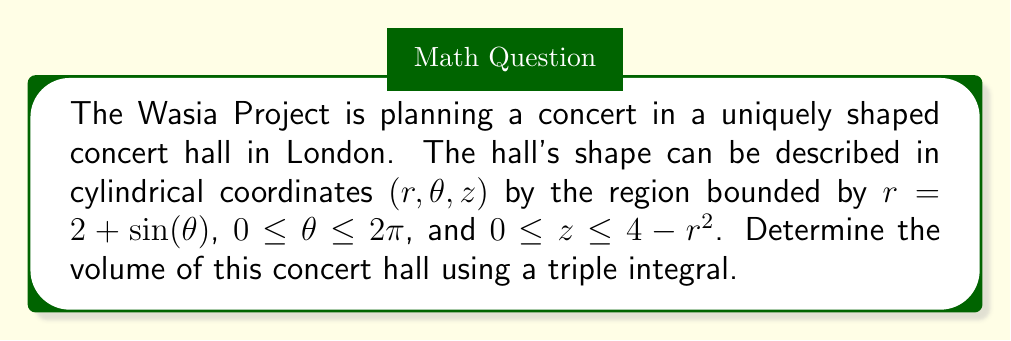Provide a solution to this math problem. To solve this problem, we'll use a triple integral in cylindrical coordinates. The steps are as follows:

1) The volume in cylindrical coordinates is given by the triple integral:

   $$V = \iiint_V r \, dr \, d\theta \, dz$$

2) From the given information, we have:
   $0 \leq \theta \leq 2\pi$
   $0 \leq r \leq 2 + \sin(\theta)$
   $0 \leq z \leq 4 - r^2$

3) We set up the triple integral:

   $$V = \int_0^{2\pi} \int_0^{2+\sin(\theta)} \int_0^{4-r^2} r \, dz \, dr \, d\theta$$

4) Let's evaluate the innermost integral first:

   $$V = \int_0^{2\pi} \int_0^{2+\sin(\theta)} r \left[ z \right]_0^{4-r^2} \, dr \, d\theta$$
   $$= \int_0^{2\pi} \int_0^{2+\sin(\theta)} r(4-r^2) \, dr \, d\theta$$

5) Now, let's evaluate the integral with respect to r:

   $$V = \int_0^{2\pi} \left[ 2r^2 - \frac{r^4}{4} \right]_0^{2+\sin(\theta)} \, d\theta$$
   $$= \int_0^{2\pi} \left[ 2(2+\sin(\theta))^2 - \frac{(2+\sin(\theta))^4}{4} \right] \, d\theta$$

6) Expand this:

   $$V = \int_0^{2\pi} \left[ 8 + 8\sin(\theta) + 2\sin^2(\theta) - \frac{16 + 32\sin(\theta) + 24\sin^2(\theta) + 8\sin^3(\theta) + \sin^4(\theta)}{4} \right] \, d\theta$$
   $$= \int_0^{2\pi} \left[ 4 + 4\sin(\theta) + \sin^2(\theta) - 2\sin^3(\theta) - \frac{1}{4}\sin^4(\theta) \right] \, d\theta$$

7) Now, we need to integrate this. Note that over $[0, 2\pi]$:
   $\int_0^{2\pi} \sin(\theta) \, d\theta = 0$
   $\int_0^{2\pi} \sin^2(\theta) \, d\theta = \pi$
   $\int_0^{2\pi} \sin^3(\theta) \, d\theta = 0$
   $\int_0^{2\pi} \sin^4(\theta) \, d\theta = \frac{3\pi}{4}$

8) Therefore:

   $$V = \left[ 4\theta + \pi - \frac{3\pi}{16} \right]_0^{2\pi}$$
   $$= 8\pi + \pi - \frac{3\pi}{16}$$
   $$= 9\pi - \frac{3\pi}{16}$$
   $$= \frac{141\pi}{16}$$

Thus, the volume of the concert hall is $\frac{141\pi}{16}$ cubic units.
Answer: $\frac{141\pi}{16}$ cubic units 